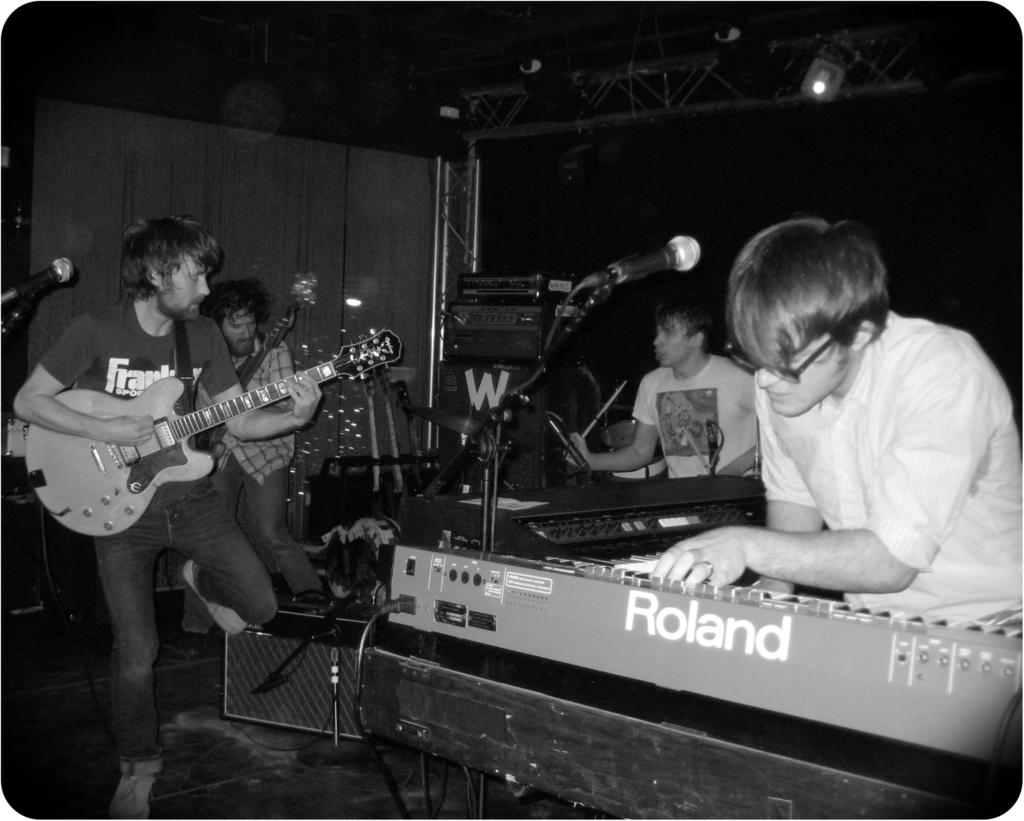Provide a one-sentence caption for the provided image. A man is playing a Roland electric keyboard with other members of a rock band. 